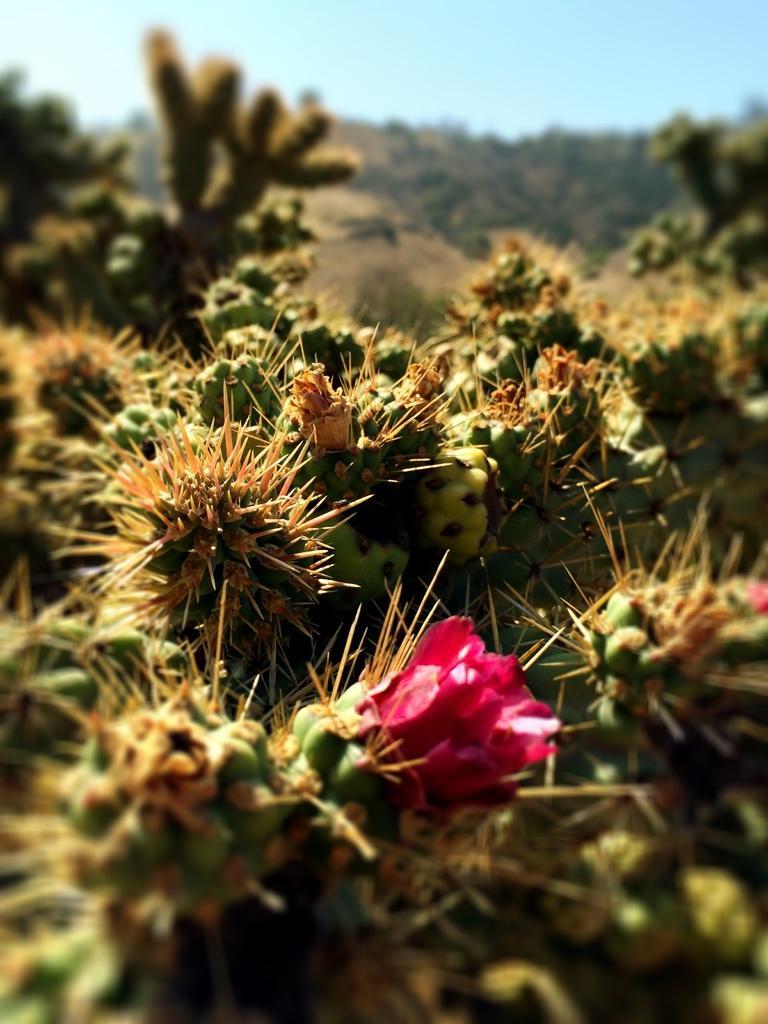How would you summarize this image in a sentence or two? These look like the cactus plants with the thorns. I can see a flower, which is red in color. The background looks blurry. I think this is the sky. 